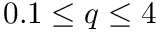<formula> <loc_0><loc_0><loc_500><loc_500>0 . 1 \leq q \leq 4</formula> 